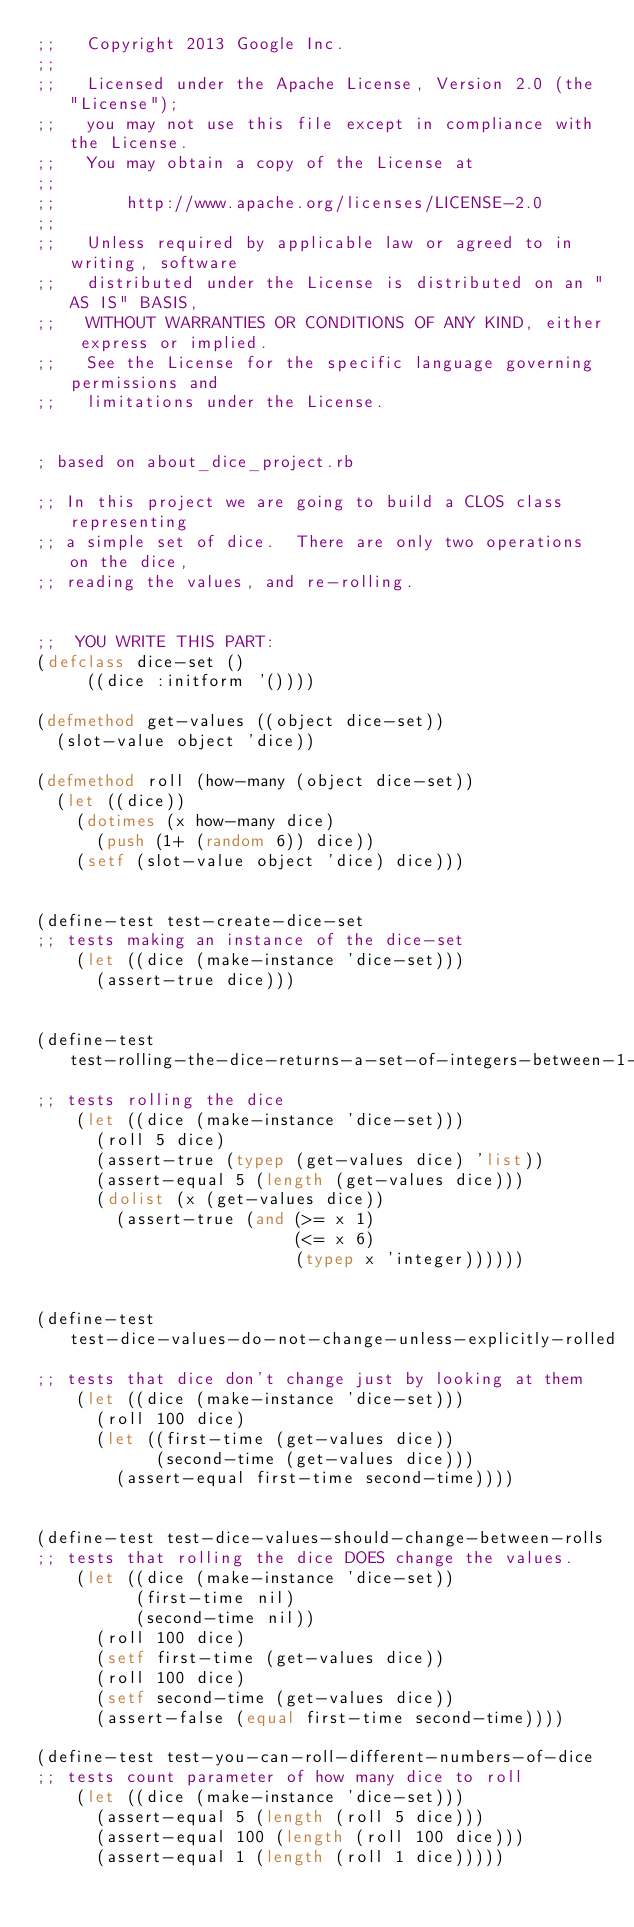<code> <loc_0><loc_0><loc_500><loc_500><_Lisp_>;;   Copyright 2013 Google Inc.
;;
;;   Licensed under the Apache License, Version 2.0 (the "License");
;;   you may not use this file except in compliance with the License.
;;   You may obtain a copy of the License at
;;
;;       http://www.apache.org/licenses/LICENSE-2.0
;;
;;   Unless required by applicable law or agreed to in writing, software
;;   distributed under the License is distributed on an "AS IS" BASIS,
;;   WITHOUT WARRANTIES OR CONDITIONS OF ANY KIND, either express or implied.
;;   See the License for the specific language governing permissions and
;;   limitations under the License.


; based on about_dice_project.rb

;; In this project we are going to build a CLOS class representing
;; a simple set of dice.  There are only two operations on the dice,
;; reading the values, and re-rolling.


;;  YOU WRITE THIS PART:
(defclass dice-set ()
     ((dice :initform '())))

(defmethod get-values ((object dice-set))
  (slot-value object 'dice))

(defmethod roll (how-many (object dice-set))
  (let ((dice))
    (dotimes (x how-many dice)
      (push (1+ (random 6)) dice))
    (setf (slot-value object 'dice) dice)))


(define-test test-create-dice-set
;; tests making an instance of the dice-set
    (let ((dice (make-instance 'dice-set)))
      (assert-true dice)))


(define-test test-rolling-the-dice-returns-a-set-of-integers-between-1-and-6
;; tests rolling the dice
    (let ((dice (make-instance 'dice-set)))
      (roll 5 dice)
      (assert-true (typep (get-values dice) 'list))
      (assert-equal 5 (length (get-values dice)))
      (dolist (x (get-values dice))
        (assert-true (and (>= x 1)
                          (<= x 6)
                          (typep x 'integer))))))


(define-test test-dice-values-do-not-change-unless-explicitly-rolled
;; tests that dice don't change just by looking at them
    (let ((dice (make-instance 'dice-set)))
      (roll 100 dice)
      (let ((first-time (get-values dice))
            (second-time (get-values dice)))
        (assert-equal first-time second-time))))


(define-test test-dice-values-should-change-between-rolls
;; tests that rolling the dice DOES change the values.
    (let ((dice (make-instance 'dice-set))
          (first-time nil)
          (second-time nil))
      (roll 100 dice)
      (setf first-time (get-values dice))
      (roll 100 dice)
      (setf second-time (get-values dice))
      (assert-false (equal first-time second-time))))

(define-test test-you-can-roll-different-numbers-of-dice
;; tests count parameter of how many dice to roll
    (let ((dice (make-instance 'dice-set)))
      (assert-equal 5 (length (roll 5 dice)))
      (assert-equal 100 (length (roll 100 dice)))
      (assert-equal 1 (length (roll 1 dice)))))
</code> 